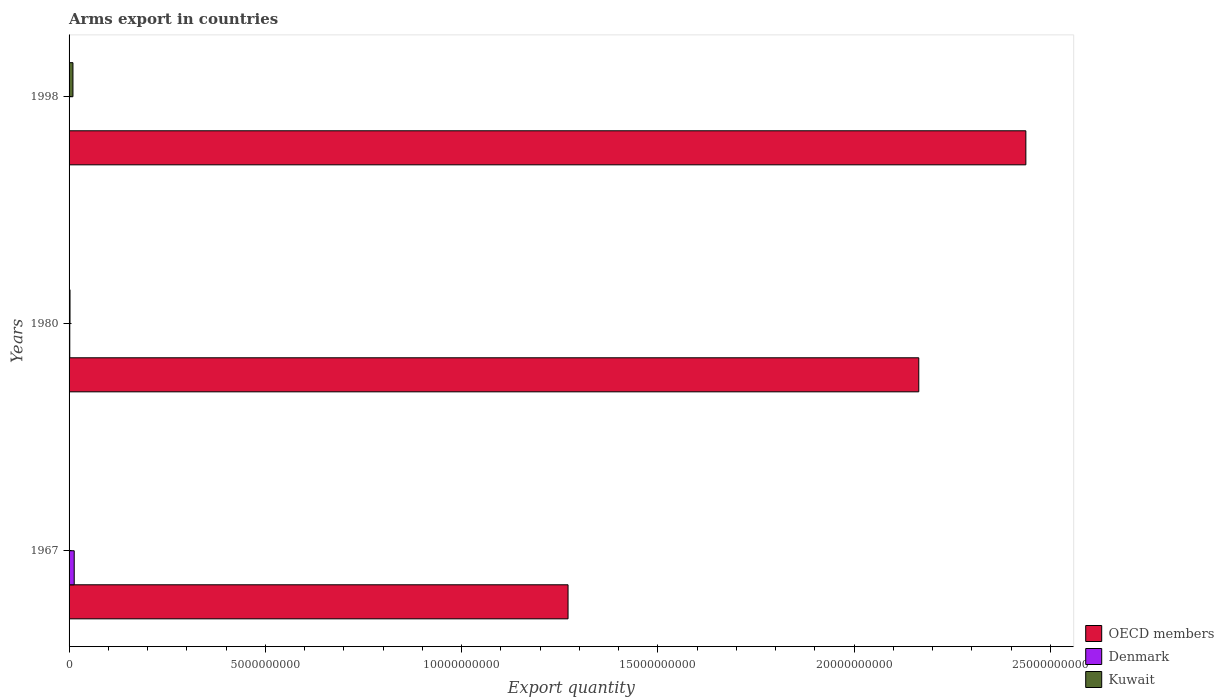How many different coloured bars are there?
Provide a succinct answer. 3. How many groups of bars are there?
Ensure brevity in your answer.  3. Are the number of bars per tick equal to the number of legend labels?
Keep it short and to the point. Yes. Are the number of bars on each tick of the Y-axis equal?
Your answer should be very brief. Yes. How many bars are there on the 3rd tick from the top?
Your answer should be very brief. 3. How many bars are there on the 1st tick from the bottom?
Provide a succinct answer. 3. What is the label of the 2nd group of bars from the top?
Ensure brevity in your answer.  1980. In how many cases, is the number of bars for a given year not equal to the number of legend labels?
Ensure brevity in your answer.  0. What is the total arms export in Denmark in 1998?
Make the answer very short. 1.00e+06. Across all years, what is the maximum total arms export in OECD members?
Offer a terse response. 2.44e+1. In which year was the total arms export in Denmark maximum?
Give a very brief answer. 1967. In which year was the total arms export in Kuwait minimum?
Give a very brief answer. 1967. What is the total total arms export in Kuwait in the graph?
Your response must be concise. 1.26e+08. What is the difference between the total arms export in Kuwait in 1967 and that in 1980?
Give a very brief answer. -2.10e+07. What is the difference between the total arms export in OECD members in 1967 and the total arms export in Kuwait in 1998?
Provide a succinct answer. 1.26e+1. What is the average total arms export in OECD members per year?
Your response must be concise. 1.96e+1. In the year 1980, what is the difference between the total arms export in Denmark and total arms export in OECD members?
Offer a terse response. -2.16e+1. What is the ratio of the total arms export in OECD members in 1980 to that in 1998?
Provide a short and direct response. 0.89. Is the total arms export in OECD members in 1967 less than that in 1980?
Your answer should be compact. Yes. Is the difference between the total arms export in Denmark in 1980 and 1998 greater than the difference between the total arms export in OECD members in 1980 and 1998?
Your response must be concise. Yes. What is the difference between the highest and the second highest total arms export in OECD members?
Provide a short and direct response. 2.73e+09. What is the difference between the highest and the lowest total arms export in Kuwait?
Keep it short and to the point. 9.60e+07. In how many years, is the total arms export in Kuwait greater than the average total arms export in Kuwait taken over all years?
Your answer should be very brief. 1. Is the sum of the total arms export in Kuwait in 1967 and 1980 greater than the maximum total arms export in OECD members across all years?
Your answer should be very brief. No. How many bars are there?
Your answer should be very brief. 9. Are the values on the major ticks of X-axis written in scientific E-notation?
Keep it short and to the point. No. Does the graph contain any zero values?
Your response must be concise. No. Where does the legend appear in the graph?
Your answer should be compact. Bottom right. How many legend labels are there?
Provide a succinct answer. 3. What is the title of the graph?
Keep it short and to the point. Arms export in countries. What is the label or title of the X-axis?
Your response must be concise. Export quantity. What is the label or title of the Y-axis?
Your answer should be very brief. Years. What is the Export quantity in OECD members in 1967?
Make the answer very short. 1.27e+1. What is the Export quantity of Denmark in 1967?
Your answer should be very brief. 1.31e+08. What is the Export quantity of OECD members in 1980?
Offer a terse response. 2.16e+1. What is the Export quantity of Denmark in 1980?
Provide a short and direct response. 1.80e+07. What is the Export quantity in Kuwait in 1980?
Give a very brief answer. 2.40e+07. What is the Export quantity of OECD members in 1998?
Your answer should be compact. 2.44e+1. What is the Export quantity in Kuwait in 1998?
Make the answer very short. 9.90e+07. Across all years, what is the maximum Export quantity of OECD members?
Provide a succinct answer. 2.44e+1. Across all years, what is the maximum Export quantity in Denmark?
Your answer should be very brief. 1.31e+08. Across all years, what is the maximum Export quantity in Kuwait?
Make the answer very short. 9.90e+07. Across all years, what is the minimum Export quantity of OECD members?
Your answer should be very brief. 1.27e+1. Across all years, what is the minimum Export quantity in Kuwait?
Keep it short and to the point. 3.00e+06. What is the total Export quantity of OECD members in the graph?
Give a very brief answer. 5.87e+1. What is the total Export quantity in Denmark in the graph?
Give a very brief answer. 1.50e+08. What is the total Export quantity of Kuwait in the graph?
Ensure brevity in your answer.  1.26e+08. What is the difference between the Export quantity of OECD members in 1967 and that in 1980?
Your response must be concise. -8.94e+09. What is the difference between the Export quantity of Denmark in 1967 and that in 1980?
Give a very brief answer. 1.13e+08. What is the difference between the Export quantity in Kuwait in 1967 and that in 1980?
Offer a terse response. -2.10e+07. What is the difference between the Export quantity of OECD members in 1967 and that in 1998?
Provide a short and direct response. -1.17e+1. What is the difference between the Export quantity of Denmark in 1967 and that in 1998?
Ensure brevity in your answer.  1.30e+08. What is the difference between the Export quantity of Kuwait in 1967 and that in 1998?
Your answer should be compact. -9.60e+07. What is the difference between the Export quantity of OECD members in 1980 and that in 1998?
Keep it short and to the point. -2.73e+09. What is the difference between the Export quantity of Denmark in 1980 and that in 1998?
Offer a very short reply. 1.70e+07. What is the difference between the Export quantity in Kuwait in 1980 and that in 1998?
Keep it short and to the point. -7.50e+07. What is the difference between the Export quantity of OECD members in 1967 and the Export quantity of Denmark in 1980?
Provide a short and direct response. 1.27e+1. What is the difference between the Export quantity of OECD members in 1967 and the Export quantity of Kuwait in 1980?
Provide a succinct answer. 1.27e+1. What is the difference between the Export quantity of Denmark in 1967 and the Export quantity of Kuwait in 1980?
Give a very brief answer. 1.07e+08. What is the difference between the Export quantity of OECD members in 1967 and the Export quantity of Denmark in 1998?
Ensure brevity in your answer.  1.27e+1. What is the difference between the Export quantity of OECD members in 1967 and the Export quantity of Kuwait in 1998?
Your answer should be compact. 1.26e+1. What is the difference between the Export quantity of Denmark in 1967 and the Export quantity of Kuwait in 1998?
Offer a terse response. 3.20e+07. What is the difference between the Export quantity in OECD members in 1980 and the Export quantity in Denmark in 1998?
Offer a terse response. 2.16e+1. What is the difference between the Export quantity of OECD members in 1980 and the Export quantity of Kuwait in 1998?
Provide a succinct answer. 2.16e+1. What is the difference between the Export quantity of Denmark in 1980 and the Export quantity of Kuwait in 1998?
Keep it short and to the point. -8.10e+07. What is the average Export quantity in OECD members per year?
Offer a very short reply. 1.96e+1. What is the average Export quantity of Denmark per year?
Your answer should be very brief. 5.00e+07. What is the average Export quantity of Kuwait per year?
Provide a short and direct response. 4.20e+07. In the year 1967, what is the difference between the Export quantity of OECD members and Export quantity of Denmark?
Offer a very short reply. 1.26e+1. In the year 1967, what is the difference between the Export quantity of OECD members and Export quantity of Kuwait?
Ensure brevity in your answer.  1.27e+1. In the year 1967, what is the difference between the Export quantity of Denmark and Export quantity of Kuwait?
Offer a very short reply. 1.28e+08. In the year 1980, what is the difference between the Export quantity in OECD members and Export quantity in Denmark?
Give a very brief answer. 2.16e+1. In the year 1980, what is the difference between the Export quantity in OECD members and Export quantity in Kuwait?
Offer a terse response. 2.16e+1. In the year 1980, what is the difference between the Export quantity of Denmark and Export quantity of Kuwait?
Your answer should be compact. -6.00e+06. In the year 1998, what is the difference between the Export quantity in OECD members and Export quantity in Denmark?
Offer a terse response. 2.44e+1. In the year 1998, what is the difference between the Export quantity in OECD members and Export quantity in Kuwait?
Your answer should be compact. 2.43e+1. In the year 1998, what is the difference between the Export quantity in Denmark and Export quantity in Kuwait?
Your response must be concise. -9.80e+07. What is the ratio of the Export quantity of OECD members in 1967 to that in 1980?
Give a very brief answer. 0.59. What is the ratio of the Export quantity of Denmark in 1967 to that in 1980?
Ensure brevity in your answer.  7.28. What is the ratio of the Export quantity in Kuwait in 1967 to that in 1980?
Make the answer very short. 0.12. What is the ratio of the Export quantity of OECD members in 1967 to that in 1998?
Provide a succinct answer. 0.52. What is the ratio of the Export quantity in Denmark in 1967 to that in 1998?
Your response must be concise. 131. What is the ratio of the Export quantity in Kuwait in 1967 to that in 1998?
Your answer should be very brief. 0.03. What is the ratio of the Export quantity of OECD members in 1980 to that in 1998?
Give a very brief answer. 0.89. What is the ratio of the Export quantity in Kuwait in 1980 to that in 1998?
Your answer should be compact. 0.24. What is the difference between the highest and the second highest Export quantity in OECD members?
Offer a terse response. 2.73e+09. What is the difference between the highest and the second highest Export quantity in Denmark?
Keep it short and to the point. 1.13e+08. What is the difference between the highest and the second highest Export quantity in Kuwait?
Make the answer very short. 7.50e+07. What is the difference between the highest and the lowest Export quantity in OECD members?
Offer a very short reply. 1.17e+1. What is the difference between the highest and the lowest Export quantity in Denmark?
Provide a short and direct response. 1.30e+08. What is the difference between the highest and the lowest Export quantity in Kuwait?
Ensure brevity in your answer.  9.60e+07. 